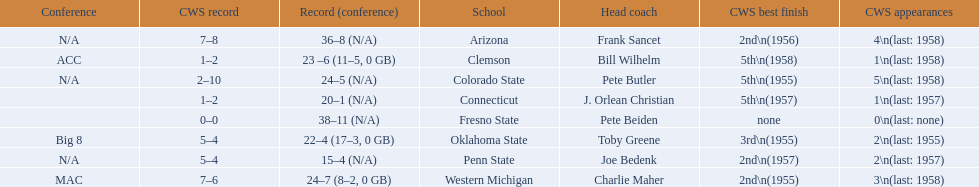What are the listed schools? Arizona, Clemson, Colorado State, Connecticut, Fresno State, Oklahoma State, Penn State, Western Michigan. Which are clemson and western michigan? Clemson, Western Michigan. What are their corresponding numbers of cws appearances? 1\n(last: 1958), 3\n(last: 1958). Which value is larger? 3\n(last: 1958). To which school does that value belong to? Western Michigan. 